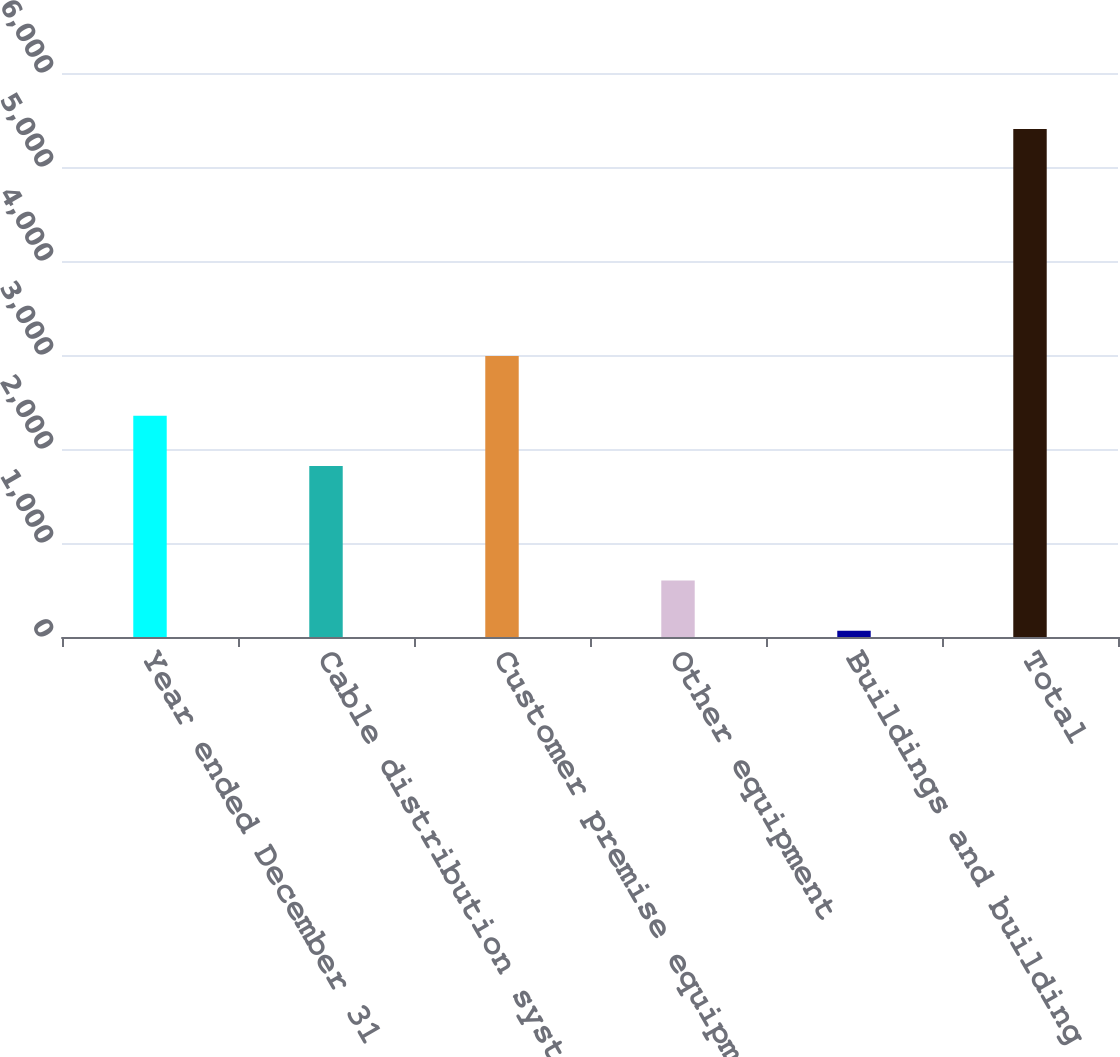Convert chart to OTSL. <chart><loc_0><loc_0><loc_500><loc_500><bar_chart><fcel>Year ended December 31 (in<fcel>Cable distribution system<fcel>Customer premise equipment<fcel>Other equipment<fcel>Buildings and building<fcel>Total<nl><fcel>2352.6<fcel>1819<fcel>2990<fcel>600.6<fcel>67<fcel>5403<nl></chart> 